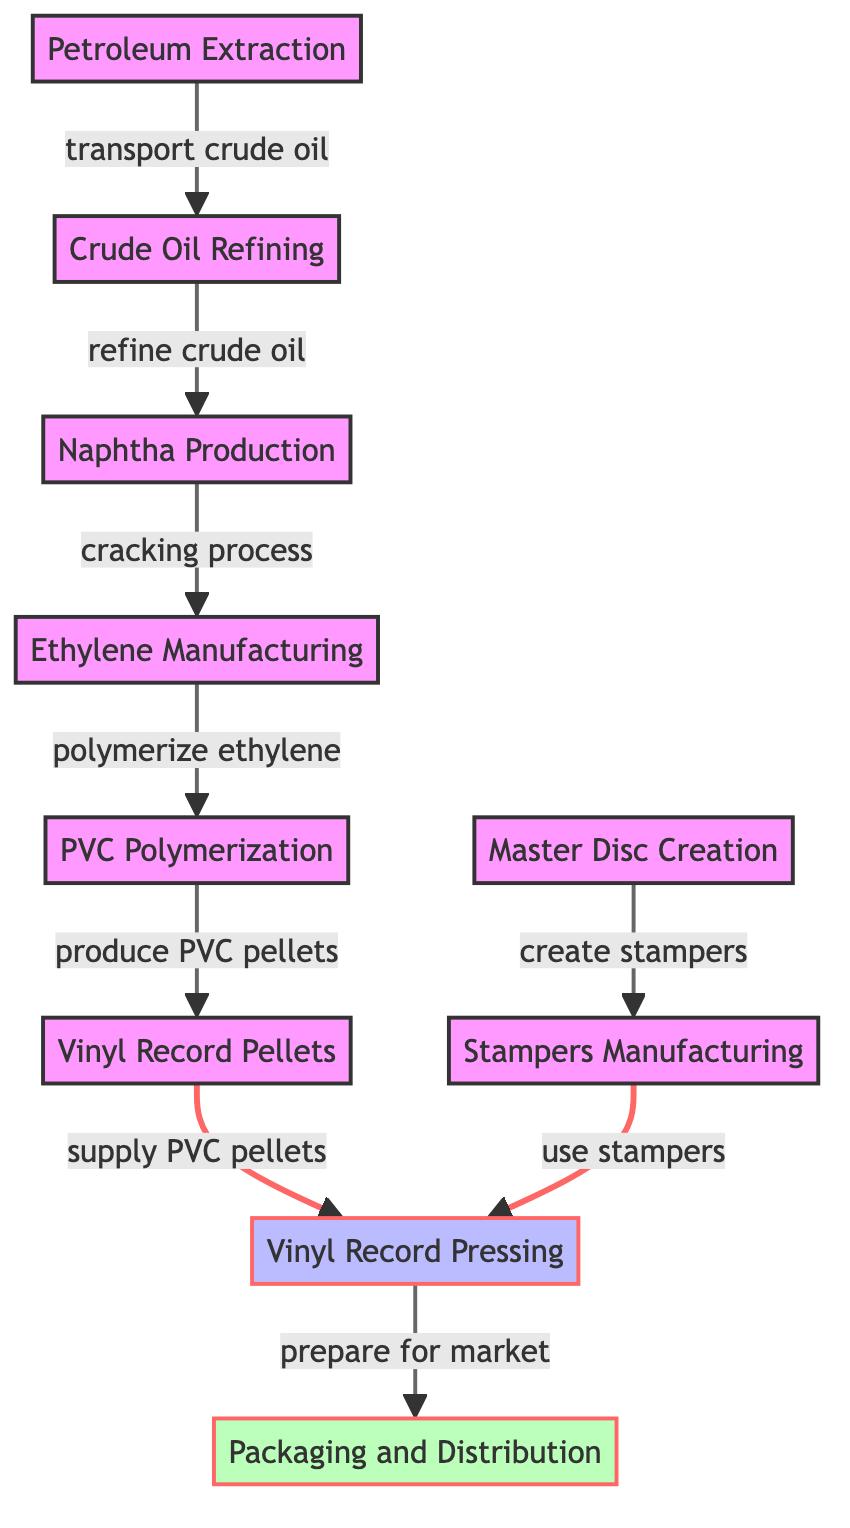What is the first step in the process? The diagram shows "Petroleum Extraction" at the beginning of the flow, indicating it is the first step in the process of producing vinyl records.
Answer: Petroleum Extraction How many steps are involved in producing vinyl records? By counting the nodes in the diagram, we see a total of 10 steps, from "Petroleum Extraction" to "Packaging and Distribution."
Answer: 10 What type of materials are produced in the "PVC Polymerization" step? The step labeled "PVC Polymerization" leads to the creation of "Vinyl Record Pellets," indicating that PVC pellets are the product of this step.
Answer: Vinyl Record Pellets What process occurs after "Naphtha Production"? The diagram indicates that "Ethylene Manufacturing" follows "Naphtha Production," showing the direct relationship between these two steps.
Answer: Ethylene Manufacturing Which step directly supplies materials to the "Vinyl Record Pressing"? According to the diagram, "Vinyl Record Pellets" are supplied directly to the "Vinyl Record Pressing" step, establishing the flow of materials.
Answer: Vinyl Record Pellets How are stampers created in the production process? The diagram shows that "Master Disc Creation" leads to "Stampers Manufacturing," indicating this is how stampers are created for the pressing process.
Answer: Stampers Manufacturing What is the final step in the vinyl record production process? By examining the diagram, it's clear that "Packaging and Distribution" is the last step, highlighting the end of the production flow.
Answer: Packaging and Distribution Which process connects to both "Master Disc Creation" and "Stampers Manufacturing"? The diagram shows that both processes are connected as "create stampers" and "use stampers," indicating they work sequentially in the production.
Answer: create stampers and use stampers Which step has an arrow connecting it to "Vinyl Record Pressing"? The diagram shows two arrows pointing towards "Vinyl Record Pressing"; one from "Vinyl Record Pellets" and the other from "Stampers Manufacturing," indicating the sources for this step.
Answer: Vinyl Record Pellets, Stampers Manufacturing What type of diagram is this? The structure and flow of the processes shown indicate that this is a natural science diagram, outlining the cultivation and use of materials in production.
Answer: Natural Science Diagram 